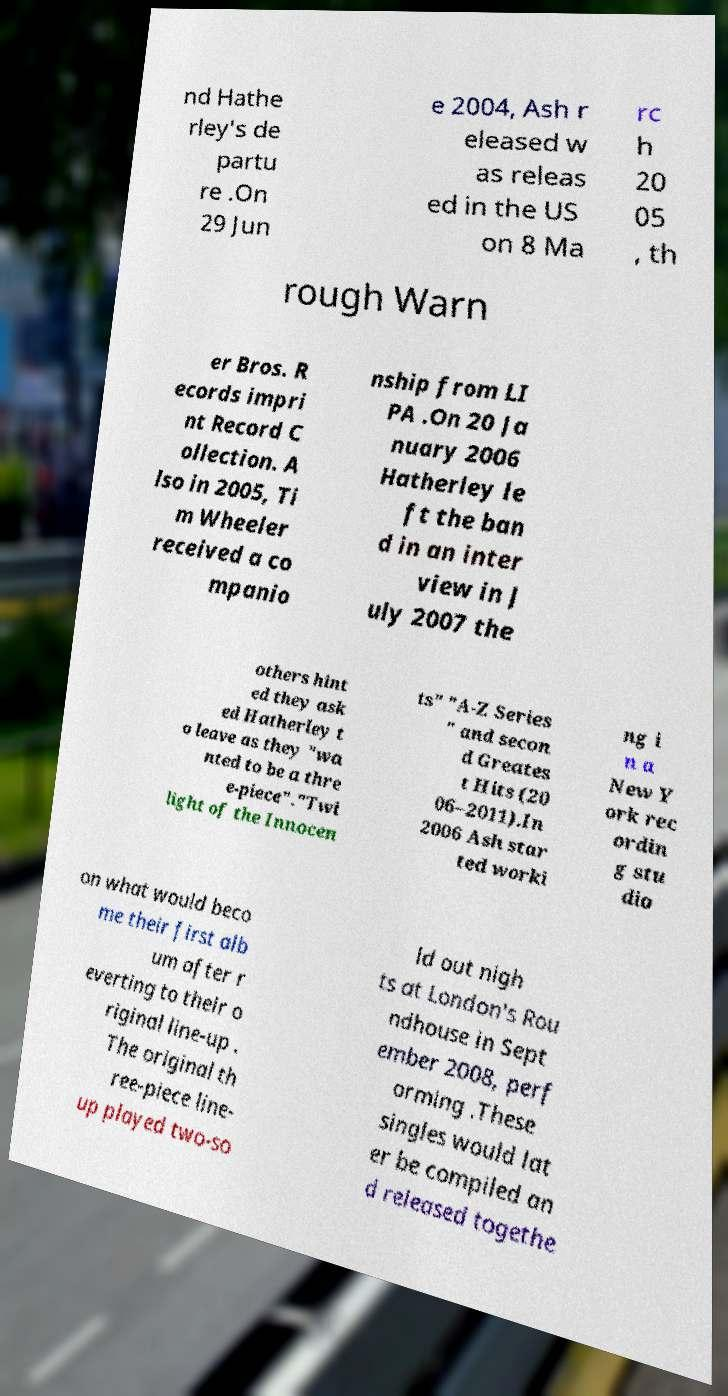Can you read and provide the text displayed in the image?This photo seems to have some interesting text. Can you extract and type it out for me? nd Hathe rley's de partu re .On 29 Jun e 2004, Ash r eleased w as releas ed in the US on 8 Ma rc h 20 05 , th rough Warn er Bros. R ecords impri nt Record C ollection. A lso in 2005, Ti m Wheeler received a co mpanio nship from LI PA .On 20 Ja nuary 2006 Hatherley le ft the ban d in an inter view in J uly 2007 the others hint ed they ask ed Hatherley t o leave as they "wa nted to be a thre e-piece"."Twi light of the Innocen ts" "A-Z Series " and secon d Greates t Hits (20 06–2011).In 2006 Ash star ted worki ng i n a New Y ork rec ordin g stu dio on what would beco me their first alb um after r everting to their o riginal line-up . The original th ree-piece line- up played two-so ld out nigh ts at London's Rou ndhouse in Sept ember 2008, perf orming .These singles would lat er be compiled an d released togethe 